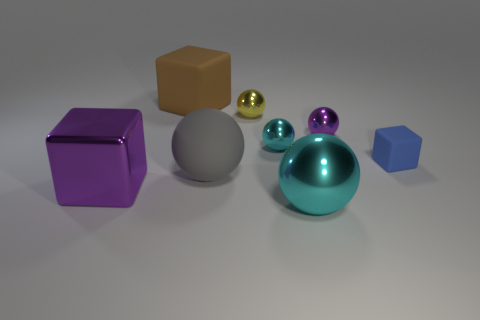There is a rubber block that is on the left side of the tiny cyan metal thing; is it the same size as the cyan thing behind the big purple object?
Offer a very short reply. No. There is a matte cube that is in front of the large brown rubber object; what color is it?
Your answer should be compact. Blue. Are there fewer brown rubber cubes that are left of the large purple block than big cyan spheres?
Keep it short and to the point. Yes. Is the material of the tiny cyan object the same as the gray sphere?
Give a very brief answer. No. There is a brown rubber object that is the same shape as the small blue matte thing; what size is it?
Offer a terse response. Large. What number of things are purple objects on the right side of the big purple thing or purple objects that are behind the small blue matte thing?
Your answer should be very brief. 1. Is the number of yellow objects less than the number of cyan matte objects?
Your response must be concise. No. There is a blue matte thing; is its size the same as the purple shiny object left of the big brown block?
Provide a succinct answer. No. How many rubber things are large purple objects or cyan spheres?
Your answer should be compact. 0. Is the number of large cyan shiny objects greater than the number of matte blocks?
Provide a succinct answer. No. 